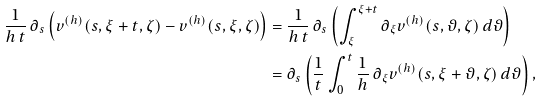Convert formula to latex. <formula><loc_0><loc_0><loc_500><loc_500>\frac { 1 } { h \, t } \, \partial _ { s } \left ( v ^ { ( h ) } ( s , \xi + t , \zeta ) - v ^ { ( h ) } ( s , \xi , \zeta ) \right ) & = \frac { 1 } { h \, t } \, \partial _ { s } \left ( \int _ { \xi } ^ { \xi + t } \partial _ { \xi } v ^ { ( h ) } ( s , \vartheta , \zeta ) \, d \vartheta \right ) \\ & = \partial _ { s } \left ( \frac { 1 } { t } \int _ { 0 } ^ { t } \frac { 1 } { h } \, \partial _ { \xi } v ^ { ( h ) } ( s , \xi + \vartheta , \zeta ) \, d \vartheta \right ) ,</formula> 